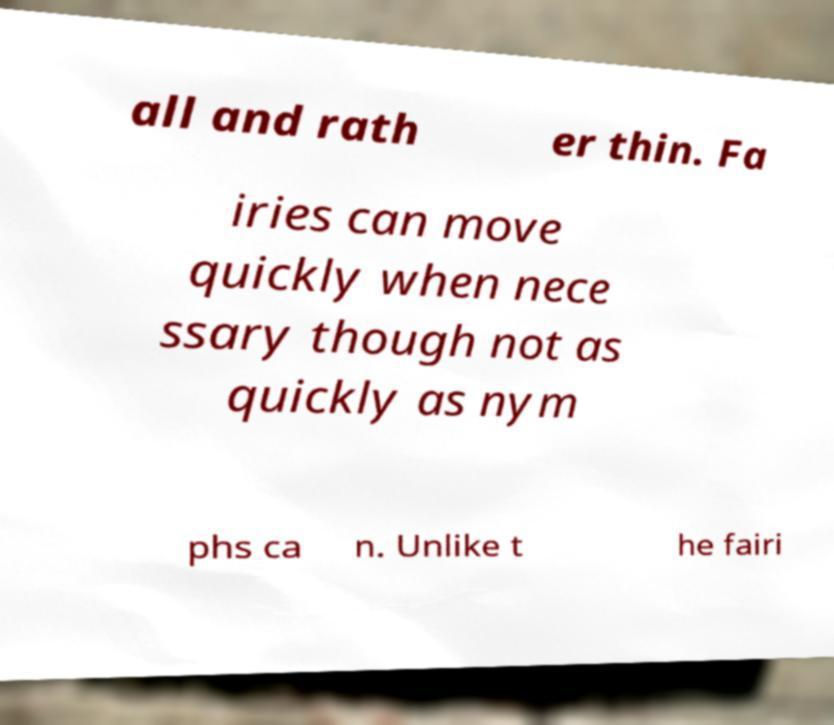Please identify and transcribe the text found in this image. all and rath er thin. Fa iries can move quickly when nece ssary though not as quickly as nym phs ca n. Unlike t he fairi 